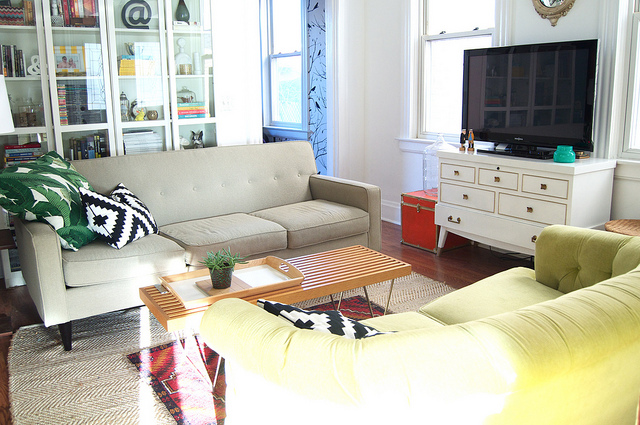What color is the vase on the right side of the white entertainment center?
A. red
B. red
C. turquoise
D. yellow
Answer with the option's letter from the given choices directly. C 